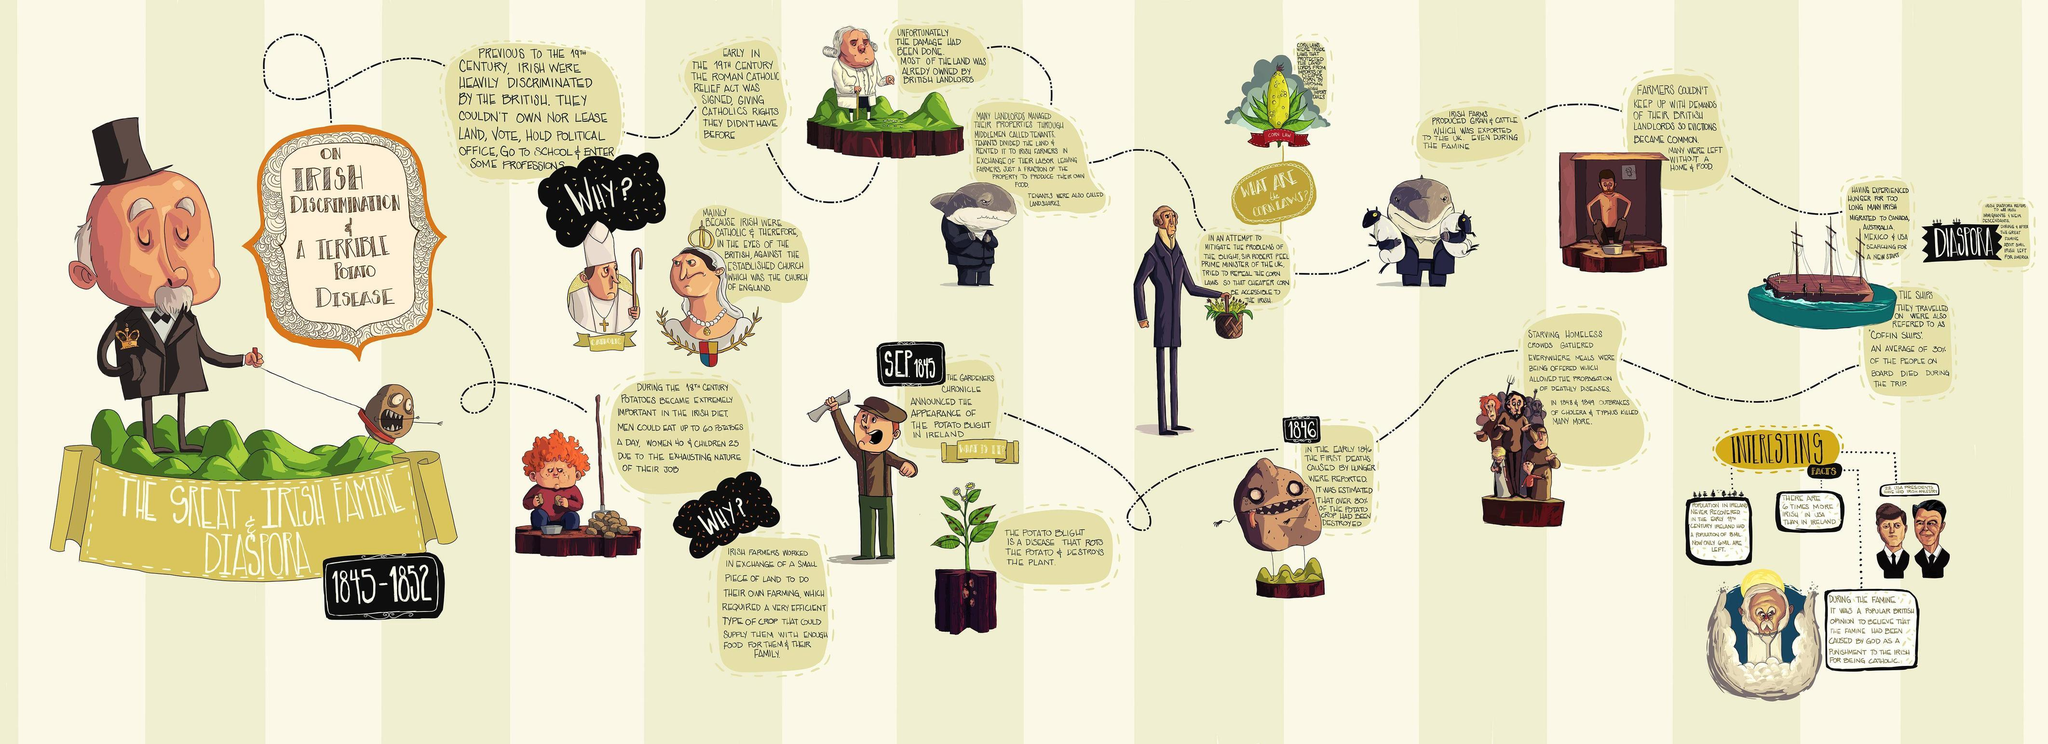Indicate a few pertinent items in this graphic. Sir Robert Peel was the British Prime Minister from 1845 to 1846. The potato blight appeared in Ireland in September 1845. Irish farmers were exchanged a small piece of land to engage in their own farming activities, in exchange for their labor. The Irish were discriminated against by the British because of their Catholic religion. Prior to the 19th century, the Irish were unable to own or lease land or vote due to their social and political marginalization. 